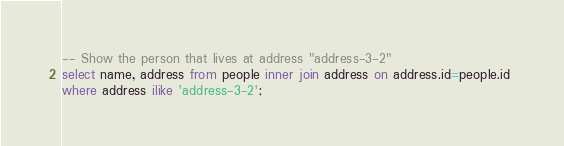<code> <loc_0><loc_0><loc_500><loc_500><_SQL_>-- Show the person that lives at address "address-3-2"
select name, address from people inner join address on address.id=people.id 
where address ilike 'address-3-2';

</code> 